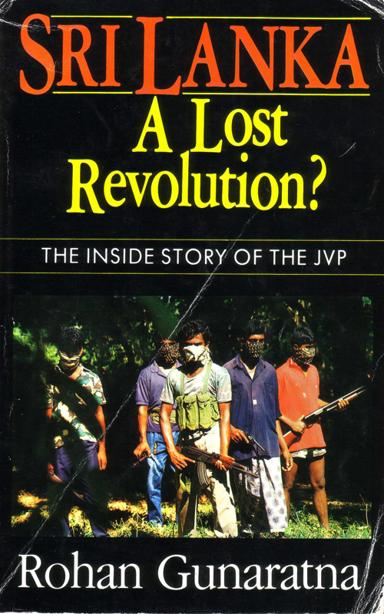What can you infer about the themes of the book based on its cover design and title? The cover design featuring armed individuals in a combative posture along with the book's title, 'Sri Lanka: A Lost Revolution?', suggests themes of conflict, uprising, and possibly the consequences of failed revolutions. It implies an analysis or narration of the revolutionary activities by the JVP and their impact on Sri Lanka's socio-political landscape. 